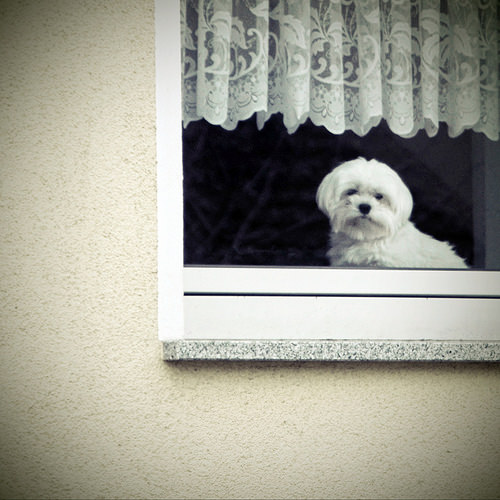<image>
Can you confirm if the dog is behind the window? Yes. From this viewpoint, the dog is positioned behind the window, with the window partially or fully occluding the dog. Is the dog in the window? Yes. The dog is contained within or inside the window, showing a containment relationship. 